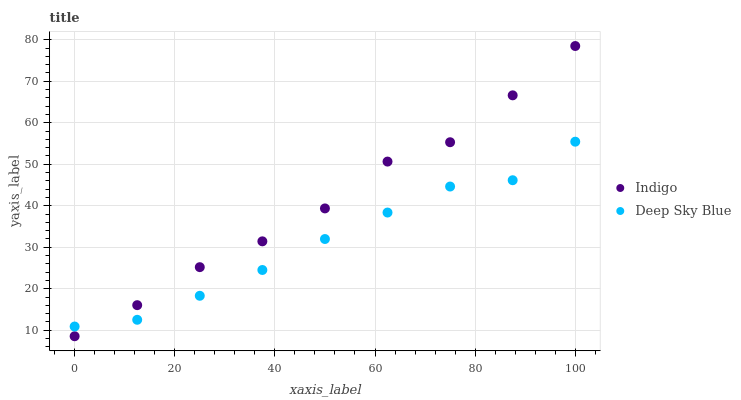Does Deep Sky Blue have the minimum area under the curve?
Answer yes or no. Yes. Does Indigo have the maximum area under the curve?
Answer yes or no. Yes. Does Deep Sky Blue have the maximum area under the curve?
Answer yes or no. No. Is Deep Sky Blue the smoothest?
Answer yes or no. Yes. Is Indigo the roughest?
Answer yes or no. Yes. Is Deep Sky Blue the roughest?
Answer yes or no. No. Does Indigo have the lowest value?
Answer yes or no. Yes. Does Deep Sky Blue have the lowest value?
Answer yes or no. No. Does Indigo have the highest value?
Answer yes or no. Yes. Does Deep Sky Blue have the highest value?
Answer yes or no. No. Does Indigo intersect Deep Sky Blue?
Answer yes or no. Yes. Is Indigo less than Deep Sky Blue?
Answer yes or no. No. Is Indigo greater than Deep Sky Blue?
Answer yes or no. No. 